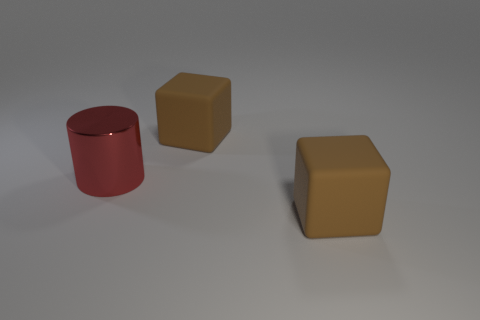Subtract 1 cubes. How many cubes are left? 1 Subtract all blue blocks. Subtract all cyan cylinders. How many blocks are left? 2 Subtract all big red shiny spheres. Subtract all brown cubes. How many objects are left? 1 Add 2 matte blocks. How many matte blocks are left? 4 Add 3 cubes. How many cubes exist? 5 Add 1 red cylinders. How many objects exist? 4 Subtract 0 red cubes. How many objects are left? 3 Subtract all cylinders. How many objects are left? 2 